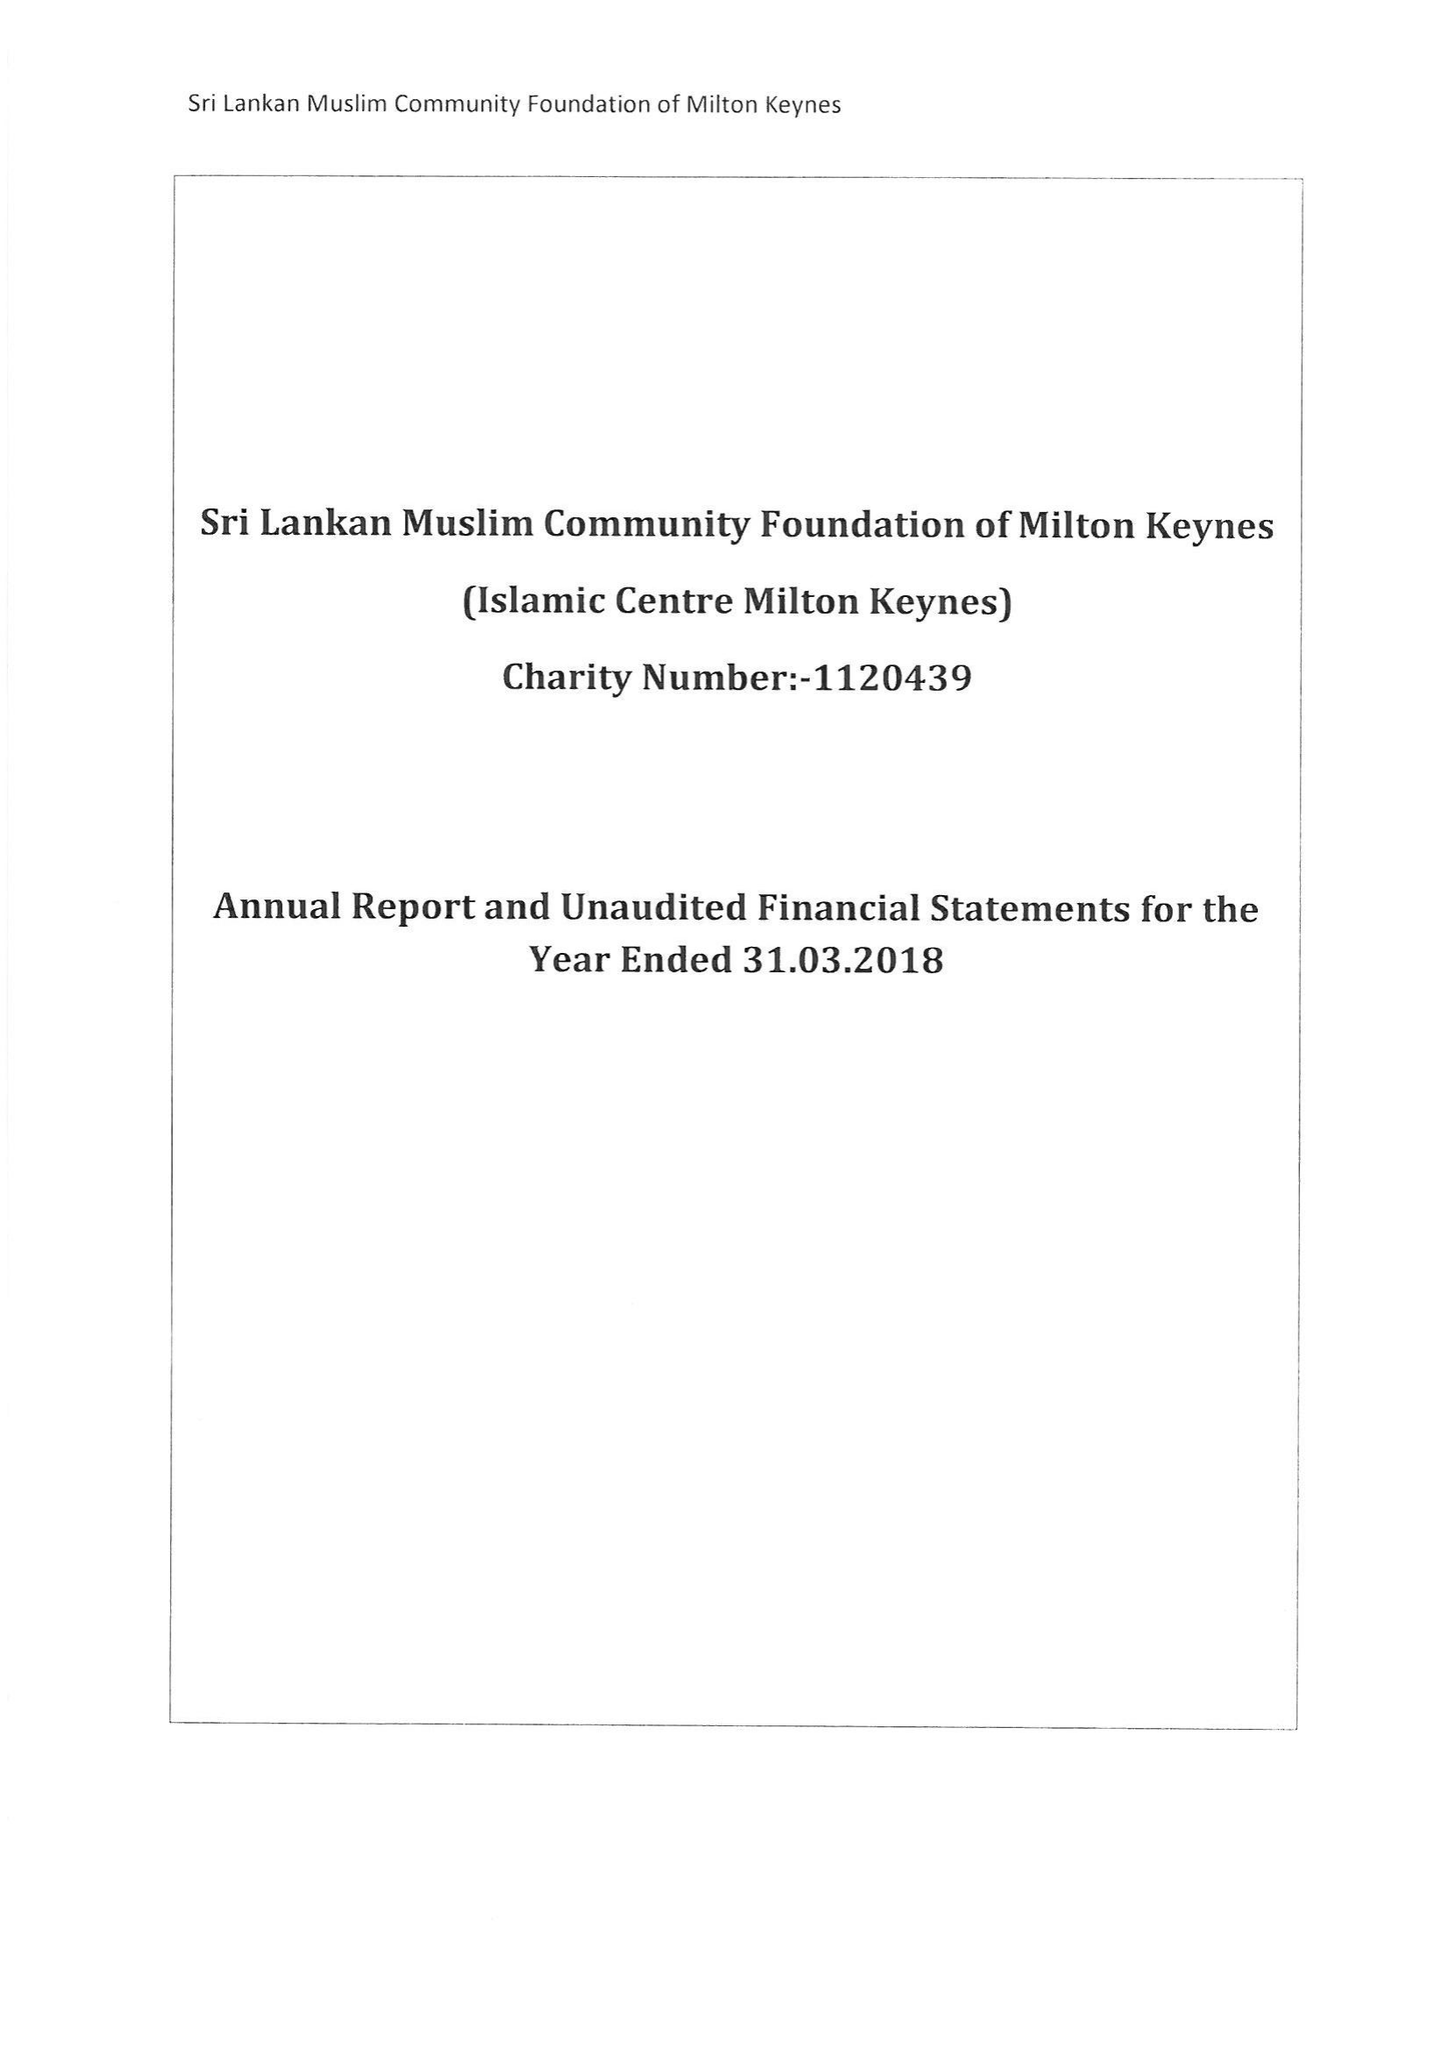What is the value for the charity_number?
Answer the question using a single word or phrase. 1120439 